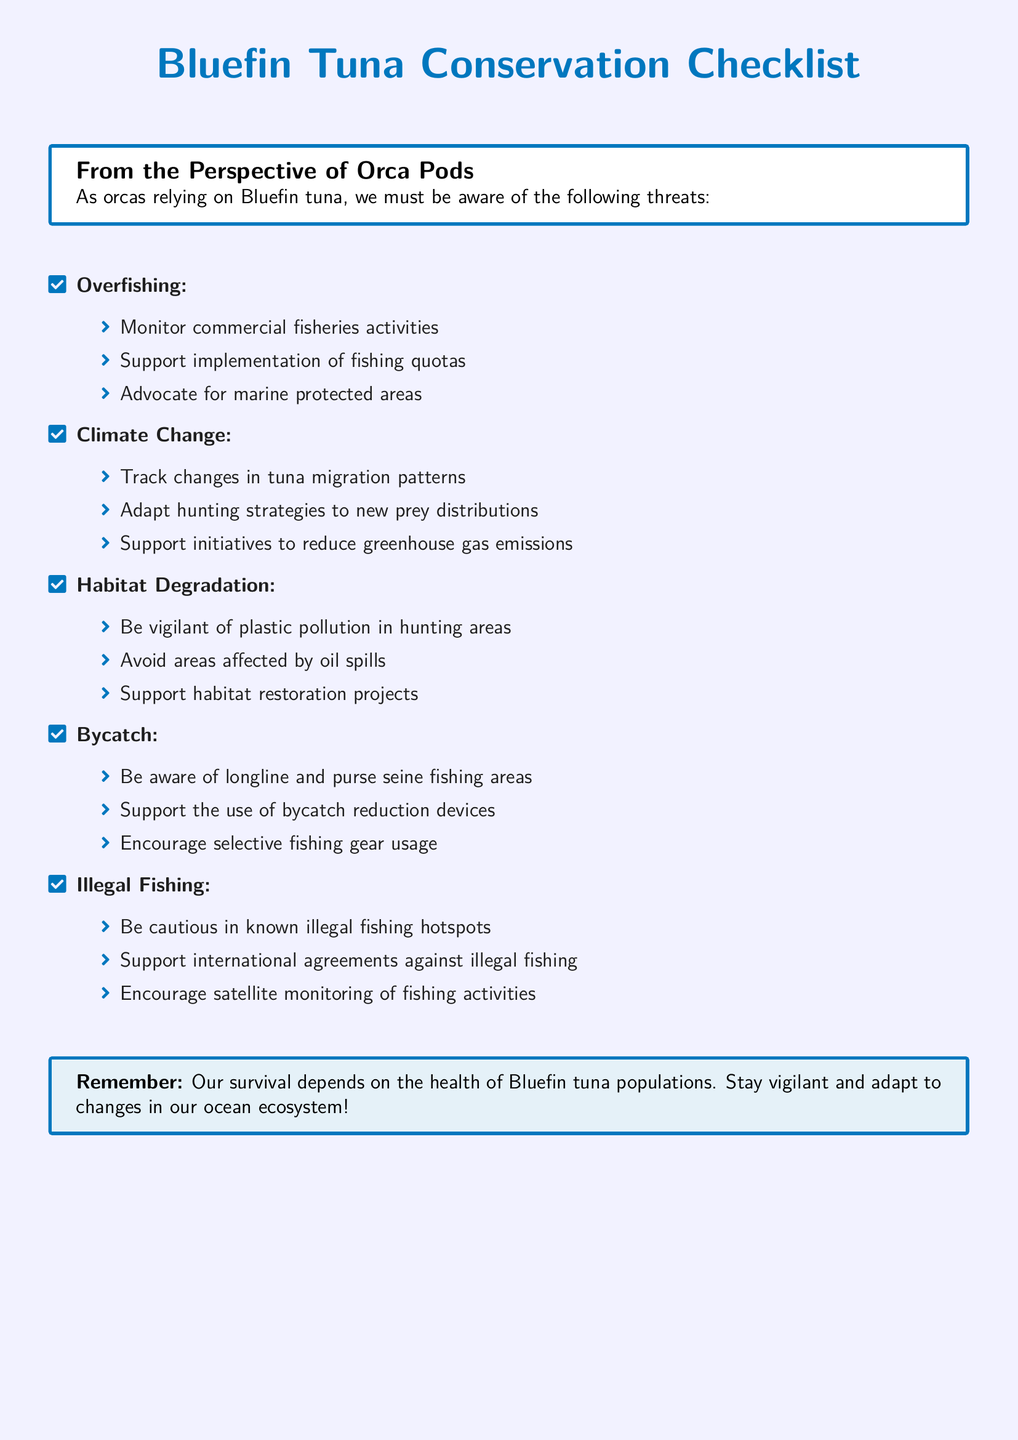what is the title of the checklist? The title of the checklist appears prominently at the top of the document.
Answer: Bluefin Tuna Conservation Checklist how many main threats to Bluefin tuna are listed? The document outlines five main threats to Bluefin tuna populations.
Answer: five name one way to monitor commercial fisheries activities. The checklist includes specific actions related to overfishing and commercial fisheries.
Answer: Monitor commercial fisheries activities what is a suggestion to combat climate change? The document provides several suggestions under each threat category, including one under climate change.
Answer: Support initiatives to reduce greenhouse gas emissions how can habitat degradation be addressed according to the checklist? The checklist lists specific actions to be taken in relation to habitat degradation.
Answer: Support habitat restoration projects which type of fishing is mentioned as a concern regarding bycatch? The document references specific fishing techniques in relation to bycatch that need to be monitored.
Answer: longline and purse seine fishing areas what should orcas do when they detect illegal fishing? The checklist advises on monitoring illegal fishing activities through strategic actions.
Answer: Encourage satellite monitoring of fishing activities name one action to adapt hunting strategies due to climate change. The document encourages adjusting hunting tactics in response to changes in prey distribution as a result of climate changes.
Answer: Adapt hunting strategies to new prey distributions 